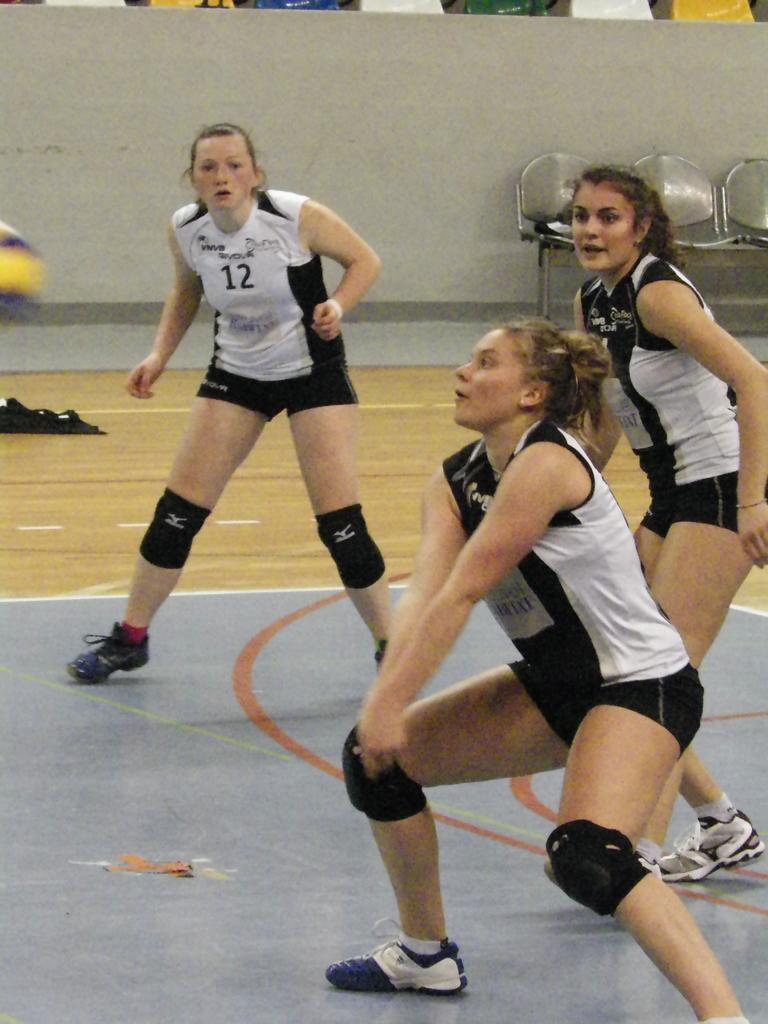How many people are present in the image? There are three persons standing in the image. Where are the persons standing? The persons are standing on the floor. What else can be seen on the floor in the image? There are objects on the floor in the image. What is visible in the background of the image? There is a wall and chairs in the background of the image. What type of vegetable is being used as a glove by one of the persons in the image? There is no vegetable being used as a glove in the image; the persons are not wearing gloves or using vegetables in that manner. 